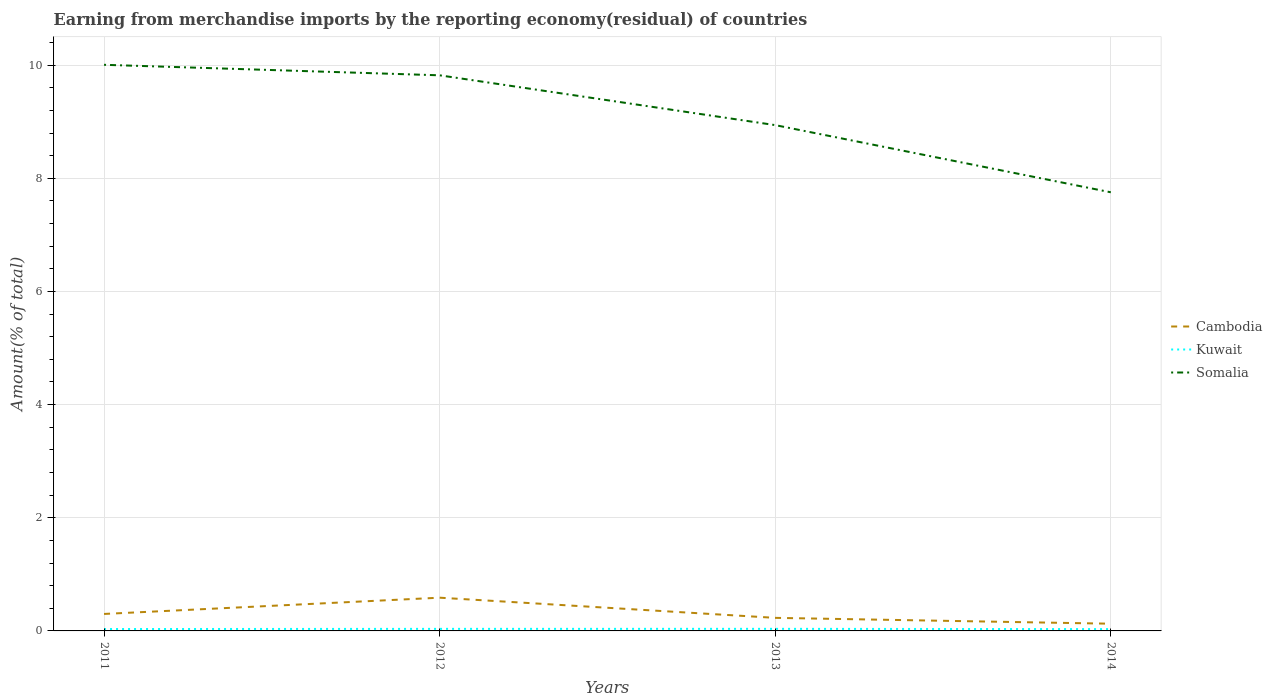How many different coloured lines are there?
Offer a terse response. 3. Does the line corresponding to Somalia intersect with the line corresponding to Cambodia?
Ensure brevity in your answer.  No. Is the number of lines equal to the number of legend labels?
Your answer should be very brief. Yes. Across all years, what is the maximum percentage of amount earned from merchandise imports in Kuwait?
Provide a succinct answer. 0.03. What is the total percentage of amount earned from merchandise imports in Kuwait in the graph?
Your answer should be compact. 0. What is the difference between the highest and the second highest percentage of amount earned from merchandise imports in Somalia?
Offer a very short reply. 2.25. How many lines are there?
Give a very brief answer. 3. How many years are there in the graph?
Your answer should be compact. 4. What is the difference between two consecutive major ticks on the Y-axis?
Offer a terse response. 2. Does the graph contain grids?
Provide a succinct answer. Yes. How many legend labels are there?
Provide a short and direct response. 3. How are the legend labels stacked?
Make the answer very short. Vertical. What is the title of the graph?
Ensure brevity in your answer.  Earning from merchandise imports by the reporting economy(residual) of countries. What is the label or title of the X-axis?
Your answer should be very brief. Years. What is the label or title of the Y-axis?
Keep it short and to the point. Amount(% of total). What is the Amount(% of total) of Cambodia in 2011?
Ensure brevity in your answer.  0.3. What is the Amount(% of total) in Kuwait in 2011?
Your response must be concise. 0.03. What is the Amount(% of total) in Somalia in 2011?
Provide a succinct answer. 10.01. What is the Amount(% of total) of Cambodia in 2012?
Offer a very short reply. 0.59. What is the Amount(% of total) in Kuwait in 2012?
Offer a very short reply. 0.04. What is the Amount(% of total) in Somalia in 2012?
Your response must be concise. 9.82. What is the Amount(% of total) of Cambodia in 2013?
Give a very brief answer. 0.23. What is the Amount(% of total) in Kuwait in 2013?
Your response must be concise. 0.04. What is the Amount(% of total) of Somalia in 2013?
Your response must be concise. 8.94. What is the Amount(% of total) in Cambodia in 2014?
Ensure brevity in your answer.  0.13. What is the Amount(% of total) of Kuwait in 2014?
Ensure brevity in your answer.  0.03. What is the Amount(% of total) of Somalia in 2014?
Provide a short and direct response. 7.75. Across all years, what is the maximum Amount(% of total) of Cambodia?
Your response must be concise. 0.59. Across all years, what is the maximum Amount(% of total) in Kuwait?
Provide a short and direct response. 0.04. Across all years, what is the maximum Amount(% of total) of Somalia?
Provide a short and direct response. 10.01. Across all years, what is the minimum Amount(% of total) of Cambodia?
Make the answer very short. 0.13. Across all years, what is the minimum Amount(% of total) in Kuwait?
Give a very brief answer. 0.03. Across all years, what is the minimum Amount(% of total) of Somalia?
Offer a very short reply. 7.75. What is the total Amount(% of total) in Cambodia in the graph?
Provide a short and direct response. 1.25. What is the total Amount(% of total) in Kuwait in the graph?
Make the answer very short. 0.14. What is the total Amount(% of total) of Somalia in the graph?
Your answer should be compact. 36.52. What is the difference between the Amount(% of total) in Cambodia in 2011 and that in 2012?
Offer a terse response. -0.29. What is the difference between the Amount(% of total) of Kuwait in 2011 and that in 2012?
Provide a succinct answer. -0. What is the difference between the Amount(% of total) of Somalia in 2011 and that in 2012?
Provide a succinct answer. 0.19. What is the difference between the Amount(% of total) of Cambodia in 2011 and that in 2013?
Your response must be concise. 0.07. What is the difference between the Amount(% of total) in Kuwait in 2011 and that in 2013?
Offer a very short reply. -0. What is the difference between the Amount(% of total) of Somalia in 2011 and that in 2013?
Make the answer very short. 1.07. What is the difference between the Amount(% of total) of Cambodia in 2011 and that in 2014?
Your answer should be very brief. 0.17. What is the difference between the Amount(% of total) of Kuwait in 2011 and that in 2014?
Offer a terse response. 0. What is the difference between the Amount(% of total) in Somalia in 2011 and that in 2014?
Give a very brief answer. 2.25. What is the difference between the Amount(% of total) in Cambodia in 2012 and that in 2013?
Provide a short and direct response. 0.36. What is the difference between the Amount(% of total) of Kuwait in 2012 and that in 2013?
Keep it short and to the point. -0. What is the difference between the Amount(% of total) in Somalia in 2012 and that in 2013?
Provide a succinct answer. 0.88. What is the difference between the Amount(% of total) of Cambodia in 2012 and that in 2014?
Make the answer very short. 0.46. What is the difference between the Amount(% of total) in Kuwait in 2012 and that in 2014?
Keep it short and to the point. 0. What is the difference between the Amount(% of total) in Somalia in 2012 and that in 2014?
Your answer should be very brief. 2.07. What is the difference between the Amount(% of total) of Cambodia in 2013 and that in 2014?
Provide a succinct answer. 0.1. What is the difference between the Amount(% of total) in Kuwait in 2013 and that in 2014?
Your answer should be very brief. 0. What is the difference between the Amount(% of total) of Somalia in 2013 and that in 2014?
Provide a succinct answer. 1.19. What is the difference between the Amount(% of total) of Cambodia in 2011 and the Amount(% of total) of Kuwait in 2012?
Make the answer very short. 0.26. What is the difference between the Amount(% of total) in Cambodia in 2011 and the Amount(% of total) in Somalia in 2012?
Your answer should be compact. -9.52. What is the difference between the Amount(% of total) in Kuwait in 2011 and the Amount(% of total) in Somalia in 2012?
Give a very brief answer. -9.79. What is the difference between the Amount(% of total) of Cambodia in 2011 and the Amount(% of total) of Kuwait in 2013?
Your response must be concise. 0.26. What is the difference between the Amount(% of total) in Cambodia in 2011 and the Amount(% of total) in Somalia in 2013?
Ensure brevity in your answer.  -8.64. What is the difference between the Amount(% of total) of Kuwait in 2011 and the Amount(% of total) of Somalia in 2013?
Your answer should be compact. -8.91. What is the difference between the Amount(% of total) of Cambodia in 2011 and the Amount(% of total) of Kuwait in 2014?
Give a very brief answer. 0.27. What is the difference between the Amount(% of total) in Cambodia in 2011 and the Amount(% of total) in Somalia in 2014?
Provide a short and direct response. -7.45. What is the difference between the Amount(% of total) of Kuwait in 2011 and the Amount(% of total) of Somalia in 2014?
Keep it short and to the point. -7.72. What is the difference between the Amount(% of total) of Cambodia in 2012 and the Amount(% of total) of Kuwait in 2013?
Give a very brief answer. 0.55. What is the difference between the Amount(% of total) of Cambodia in 2012 and the Amount(% of total) of Somalia in 2013?
Ensure brevity in your answer.  -8.35. What is the difference between the Amount(% of total) of Kuwait in 2012 and the Amount(% of total) of Somalia in 2013?
Your response must be concise. -8.9. What is the difference between the Amount(% of total) of Cambodia in 2012 and the Amount(% of total) of Kuwait in 2014?
Your answer should be compact. 0.56. What is the difference between the Amount(% of total) in Cambodia in 2012 and the Amount(% of total) in Somalia in 2014?
Give a very brief answer. -7.16. What is the difference between the Amount(% of total) of Kuwait in 2012 and the Amount(% of total) of Somalia in 2014?
Give a very brief answer. -7.72. What is the difference between the Amount(% of total) of Cambodia in 2013 and the Amount(% of total) of Kuwait in 2014?
Keep it short and to the point. 0.2. What is the difference between the Amount(% of total) of Cambodia in 2013 and the Amount(% of total) of Somalia in 2014?
Your response must be concise. -7.52. What is the difference between the Amount(% of total) in Kuwait in 2013 and the Amount(% of total) in Somalia in 2014?
Ensure brevity in your answer.  -7.72. What is the average Amount(% of total) in Cambodia per year?
Provide a short and direct response. 0.31. What is the average Amount(% of total) in Kuwait per year?
Your answer should be compact. 0.03. What is the average Amount(% of total) in Somalia per year?
Offer a terse response. 9.13. In the year 2011, what is the difference between the Amount(% of total) of Cambodia and Amount(% of total) of Kuwait?
Make the answer very short. 0.27. In the year 2011, what is the difference between the Amount(% of total) of Cambodia and Amount(% of total) of Somalia?
Offer a very short reply. -9.71. In the year 2011, what is the difference between the Amount(% of total) of Kuwait and Amount(% of total) of Somalia?
Provide a succinct answer. -9.97. In the year 2012, what is the difference between the Amount(% of total) of Cambodia and Amount(% of total) of Kuwait?
Make the answer very short. 0.55. In the year 2012, what is the difference between the Amount(% of total) of Cambodia and Amount(% of total) of Somalia?
Ensure brevity in your answer.  -9.23. In the year 2012, what is the difference between the Amount(% of total) of Kuwait and Amount(% of total) of Somalia?
Offer a very short reply. -9.78. In the year 2013, what is the difference between the Amount(% of total) of Cambodia and Amount(% of total) of Kuwait?
Provide a succinct answer. 0.19. In the year 2013, what is the difference between the Amount(% of total) of Cambodia and Amount(% of total) of Somalia?
Provide a succinct answer. -8.71. In the year 2013, what is the difference between the Amount(% of total) of Kuwait and Amount(% of total) of Somalia?
Provide a short and direct response. -8.9. In the year 2014, what is the difference between the Amount(% of total) in Cambodia and Amount(% of total) in Kuwait?
Ensure brevity in your answer.  0.1. In the year 2014, what is the difference between the Amount(% of total) in Cambodia and Amount(% of total) in Somalia?
Your answer should be very brief. -7.62. In the year 2014, what is the difference between the Amount(% of total) of Kuwait and Amount(% of total) of Somalia?
Your answer should be very brief. -7.72. What is the ratio of the Amount(% of total) in Cambodia in 2011 to that in 2012?
Provide a succinct answer. 0.51. What is the ratio of the Amount(% of total) in Kuwait in 2011 to that in 2012?
Provide a short and direct response. 0.92. What is the ratio of the Amount(% of total) of Somalia in 2011 to that in 2012?
Offer a very short reply. 1.02. What is the ratio of the Amount(% of total) of Cambodia in 2011 to that in 2013?
Your answer should be very brief. 1.3. What is the ratio of the Amount(% of total) in Kuwait in 2011 to that in 2013?
Keep it short and to the point. 0.91. What is the ratio of the Amount(% of total) in Somalia in 2011 to that in 2013?
Your answer should be very brief. 1.12. What is the ratio of the Amount(% of total) in Cambodia in 2011 to that in 2014?
Provide a short and direct response. 2.35. What is the ratio of the Amount(% of total) in Kuwait in 2011 to that in 2014?
Keep it short and to the point. 1.04. What is the ratio of the Amount(% of total) of Somalia in 2011 to that in 2014?
Offer a terse response. 1.29. What is the ratio of the Amount(% of total) in Cambodia in 2012 to that in 2013?
Provide a short and direct response. 2.54. What is the ratio of the Amount(% of total) of Kuwait in 2012 to that in 2013?
Your response must be concise. 0.99. What is the ratio of the Amount(% of total) of Somalia in 2012 to that in 2013?
Make the answer very short. 1.1. What is the ratio of the Amount(% of total) of Cambodia in 2012 to that in 2014?
Provide a short and direct response. 4.61. What is the ratio of the Amount(% of total) in Kuwait in 2012 to that in 2014?
Keep it short and to the point. 1.13. What is the ratio of the Amount(% of total) of Somalia in 2012 to that in 2014?
Make the answer very short. 1.27. What is the ratio of the Amount(% of total) in Cambodia in 2013 to that in 2014?
Provide a short and direct response. 1.81. What is the ratio of the Amount(% of total) in Kuwait in 2013 to that in 2014?
Make the answer very short. 1.15. What is the ratio of the Amount(% of total) in Somalia in 2013 to that in 2014?
Your answer should be very brief. 1.15. What is the difference between the highest and the second highest Amount(% of total) in Cambodia?
Your answer should be very brief. 0.29. What is the difference between the highest and the second highest Amount(% of total) in Kuwait?
Keep it short and to the point. 0. What is the difference between the highest and the second highest Amount(% of total) of Somalia?
Your answer should be compact. 0.19. What is the difference between the highest and the lowest Amount(% of total) of Cambodia?
Make the answer very short. 0.46. What is the difference between the highest and the lowest Amount(% of total) in Kuwait?
Keep it short and to the point. 0. What is the difference between the highest and the lowest Amount(% of total) of Somalia?
Give a very brief answer. 2.25. 